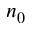Convert formula to latex. <formula><loc_0><loc_0><loc_500><loc_500>n _ { 0 }</formula> 